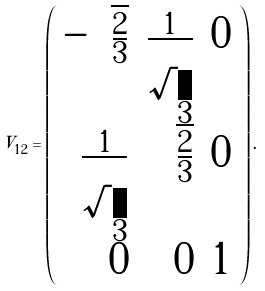Convert formula to latex. <formula><loc_0><loc_0><loc_500><loc_500>V _ { 1 2 } = \left ( \begin{array} { r r r } - \sqrt { \frac { 2 } { 3 } } & { \frac { 1 } { \sqrt { 3 } } } & 0 \\ { \frac { 1 } { \sqrt { 3 } } } & \sqrt { \frac { 2 } { 3 } } & { 0 } \\ { 0 } & { 0 } & { 1 } \end{array} \right ) .</formula> 